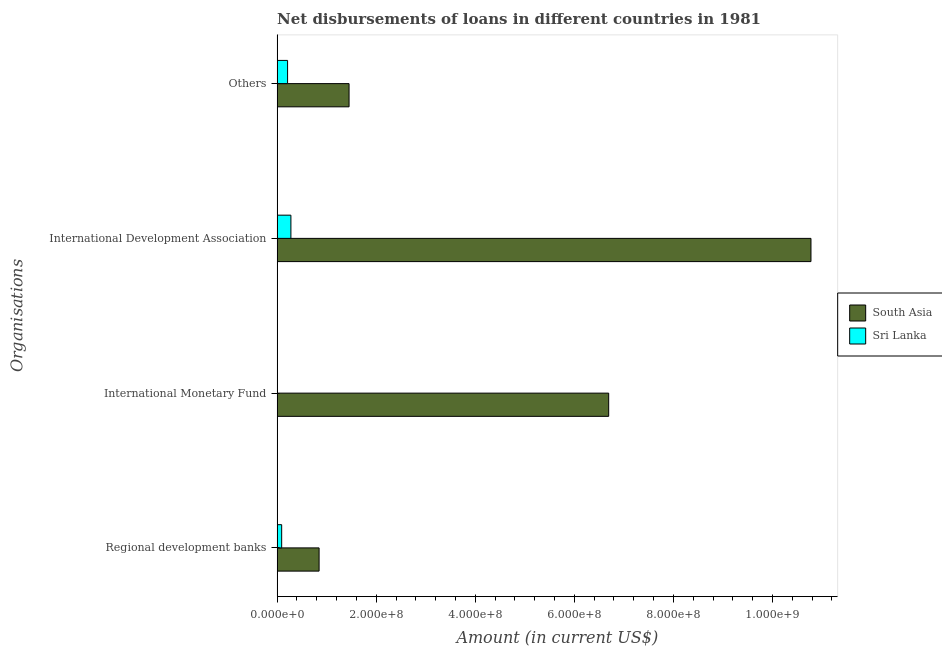How many different coloured bars are there?
Offer a very short reply. 2. How many groups of bars are there?
Your answer should be compact. 4. Are the number of bars per tick equal to the number of legend labels?
Offer a very short reply. Yes. How many bars are there on the 4th tick from the bottom?
Keep it short and to the point. 2. What is the label of the 4th group of bars from the top?
Ensure brevity in your answer.  Regional development banks. What is the amount of loan disimbursed by international monetary fund in Sri Lanka?
Give a very brief answer. 4.37e+05. Across all countries, what is the maximum amount of loan disimbursed by regional development banks?
Ensure brevity in your answer.  8.47e+07. Across all countries, what is the minimum amount of loan disimbursed by international development association?
Give a very brief answer. 2.78e+07. In which country was the amount of loan disimbursed by regional development banks maximum?
Provide a succinct answer. South Asia. In which country was the amount of loan disimbursed by regional development banks minimum?
Ensure brevity in your answer.  Sri Lanka. What is the total amount of loan disimbursed by international monetary fund in the graph?
Keep it short and to the point. 6.70e+08. What is the difference between the amount of loan disimbursed by international monetary fund in Sri Lanka and that in South Asia?
Give a very brief answer. -6.69e+08. What is the difference between the amount of loan disimbursed by regional development banks in Sri Lanka and the amount of loan disimbursed by other organisations in South Asia?
Provide a succinct answer. -1.36e+08. What is the average amount of loan disimbursed by regional development banks per country?
Offer a terse response. 4.70e+07. What is the difference between the amount of loan disimbursed by international monetary fund and amount of loan disimbursed by international development association in South Asia?
Your response must be concise. -4.08e+08. In how many countries, is the amount of loan disimbursed by international monetary fund greater than 1080000000 US$?
Keep it short and to the point. 0. What is the ratio of the amount of loan disimbursed by international development association in South Asia to that in Sri Lanka?
Your answer should be compact. 38.73. Is the amount of loan disimbursed by international development association in South Asia less than that in Sri Lanka?
Offer a terse response. No. Is the difference between the amount of loan disimbursed by regional development banks in Sri Lanka and South Asia greater than the difference between the amount of loan disimbursed by other organisations in Sri Lanka and South Asia?
Ensure brevity in your answer.  Yes. What is the difference between the highest and the second highest amount of loan disimbursed by international monetary fund?
Make the answer very short. 6.69e+08. What is the difference between the highest and the lowest amount of loan disimbursed by international monetary fund?
Provide a succinct answer. 6.69e+08. What does the 2nd bar from the top in International Monetary Fund represents?
Offer a terse response. South Asia. Is it the case that in every country, the sum of the amount of loan disimbursed by regional development banks and amount of loan disimbursed by international monetary fund is greater than the amount of loan disimbursed by international development association?
Make the answer very short. No. Are all the bars in the graph horizontal?
Provide a succinct answer. Yes. How many countries are there in the graph?
Make the answer very short. 2. What is the difference between two consecutive major ticks on the X-axis?
Ensure brevity in your answer.  2.00e+08. Are the values on the major ticks of X-axis written in scientific E-notation?
Your response must be concise. Yes. Does the graph contain any zero values?
Provide a short and direct response. No. Where does the legend appear in the graph?
Keep it short and to the point. Center right. How are the legend labels stacked?
Provide a short and direct response. Vertical. What is the title of the graph?
Ensure brevity in your answer.  Net disbursements of loans in different countries in 1981. Does "Belgium" appear as one of the legend labels in the graph?
Give a very brief answer. No. What is the label or title of the Y-axis?
Your answer should be compact. Organisations. What is the Amount (in current US$) of South Asia in Regional development banks?
Offer a terse response. 8.47e+07. What is the Amount (in current US$) of Sri Lanka in Regional development banks?
Your answer should be compact. 9.17e+06. What is the Amount (in current US$) in South Asia in International Monetary Fund?
Give a very brief answer. 6.69e+08. What is the Amount (in current US$) in Sri Lanka in International Monetary Fund?
Offer a terse response. 4.37e+05. What is the Amount (in current US$) of South Asia in International Development Association?
Ensure brevity in your answer.  1.08e+09. What is the Amount (in current US$) of Sri Lanka in International Development Association?
Make the answer very short. 2.78e+07. What is the Amount (in current US$) in South Asia in Others?
Your answer should be very brief. 1.45e+08. What is the Amount (in current US$) of Sri Lanka in Others?
Offer a terse response. 2.11e+07. Across all Organisations, what is the maximum Amount (in current US$) of South Asia?
Your answer should be compact. 1.08e+09. Across all Organisations, what is the maximum Amount (in current US$) of Sri Lanka?
Keep it short and to the point. 2.78e+07. Across all Organisations, what is the minimum Amount (in current US$) in South Asia?
Offer a very short reply. 8.47e+07. Across all Organisations, what is the minimum Amount (in current US$) in Sri Lanka?
Keep it short and to the point. 4.37e+05. What is the total Amount (in current US$) of South Asia in the graph?
Your answer should be very brief. 1.98e+09. What is the total Amount (in current US$) in Sri Lanka in the graph?
Give a very brief answer. 5.85e+07. What is the difference between the Amount (in current US$) of South Asia in Regional development banks and that in International Monetary Fund?
Ensure brevity in your answer.  -5.85e+08. What is the difference between the Amount (in current US$) of Sri Lanka in Regional development banks and that in International Monetary Fund?
Give a very brief answer. 8.73e+06. What is the difference between the Amount (in current US$) in South Asia in Regional development banks and that in International Development Association?
Make the answer very short. -9.93e+08. What is the difference between the Amount (in current US$) of Sri Lanka in Regional development banks and that in International Development Association?
Provide a short and direct response. -1.87e+07. What is the difference between the Amount (in current US$) in South Asia in Regional development banks and that in Others?
Offer a terse response. -6.05e+07. What is the difference between the Amount (in current US$) in Sri Lanka in Regional development banks and that in Others?
Make the answer very short. -1.19e+07. What is the difference between the Amount (in current US$) of South Asia in International Monetary Fund and that in International Development Association?
Give a very brief answer. -4.08e+08. What is the difference between the Amount (in current US$) in Sri Lanka in International Monetary Fund and that in International Development Association?
Provide a succinct answer. -2.74e+07. What is the difference between the Amount (in current US$) in South Asia in International Monetary Fund and that in Others?
Give a very brief answer. 5.24e+08. What is the difference between the Amount (in current US$) of Sri Lanka in International Monetary Fund and that in Others?
Keep it short and to the point. -2.07e+07. What is the difference between the Amount (in current US$) of South Asia in International Development Association and that in Others?
Provide a succinct answer. 9.33e+08. What is the difference between the Amount (in current US$) of Sri Lanka in International Development Association and that in Others?
Give a very brief answer. 6.72e+06. What is the difference between the Amount (in current US$) in South Asia in Regional development banks and the Amount (in current US$) in Sri Lanka in International Monetary Fund?
Provide a short and direct response. 8.43e+07. What is the difference between the Amount (in current US$) of South Asia in Regional development banks and the Amount (in current US$) of Sri Lanka in International Development Association?
Your answer should be very brief. 5.69e+07. What is the difference between the Amount (in current US$) of South Asia in Regional development banks and the Amount (in current US$) of Sri Lanka in Others?
Your response must be concise. 6.36e+07. What is the difference between the Amount (in current US$) in South Asia in International Monetary Fund and the Amount (in current US$) in Sri Lanka in International Development Association?
Your response must be concise. 6.42e+08. What is the difference between the Amount (in current US$) in South Asia in International Monetary Fund and the Amount (in current US$) in Sri Lanka in Others?
Make the answer very short. 6.48e+08. What is the difference between the Amount (in current US$) of South Asia in International Development Association and the Amount (in current US$) of Sri Lanka in Others?
Keep it short and to the point. 1.06e+09. What is the average Amount (in current US$) of South Asia per Organisations?
Your response must be concise. 4.94e+08. What is the average Amount (in current US$) of Sri Lanka per Organisations?
Your answer should be compact. 1.46e+07. What is the difference between the Amount (in current US$) of South Asia and Amount (in current US$) of Sri Lanka in Regional development banks?
Provide a short and direct response. 7.56e+07. What is the difference between the Amount (in current US$) of South Asia and Amount (in current US$) of Sri Lanka in International Monetary Fund?
Offer a terse response. 6.69e+08. What is the difference between the Amount (in current US$) of South Asia and Amount (in current US$) of Sri Lanka in International Development Association?
Your answer should be very brief. 1.05e+09. What is the difference between the Amount (in current US$) in South Asia and Amount (in current US$) in Sri Lanka in Others?
Your answer should be compact. 1.24e+08. What is the ratio of the Amount (in current US$) of South Asia in Regional development banks to that in International Monetary Fund?
Your answer should be very brief. 0.13. What is the ratio of the Amount (in current US$) of Sri Lanka in Regional development banks to that in International Monetary Fund?
Ensure brevity in your answer.  20.98. What is the ratio of the Amount (in current US$) in South Asia in Regional development banks to that in International Development Association?
Keep it short and to the point. 0.08. What is the ratio of the Amount (in current US$) in Sri Lanka in Regional development banks to that in International Development Association?
Provide a short and direct response. 0.33. What is the ratio of the Amount (in current US$) in South Asia in Regional development banks to that in Others?
Offer a terse response. 0.58. What is the ratio of the Amount (in current US$) in Sri Lanka in Regional development banks to that in Others?
Offer a very short reply. 0.43. What is the ratio of the Amount (in current US$) in South Asia in International Monetary Fund to that in International Development Association?
Give a very brief answer. 0.62. What is the ratio of the Amount (in current US$) in Sri Lanka in International Monetary Fund to that in International Development Association?
Make the answer very short. 0.02. What is the ratio of the Amount (in current US$) of South Asia in International Monetary Fund to that in Others?
Your answer should be compact. 4.61. What is the ratio of the Amount (in current US$) in Sri Lanka in International Monetary Fund to that in Others?
Your response must be concise. 0.02. What is the ratio of the Amount (in current US$) in South Asia in International Development Association to that in Others?
Keep it short and to the point. 7.42. What is the ratio of the Amount (in current US$) in Sri Lanka in International Development Association to that in Others?
Your answer should be compact. 1.32. What is the difference between the highest and the second highest Amount (in current US$) in South Asia?
Your answer should be very brief. 4.08e+08. What is the difference between the highest and the second highest Amount (in current US$) of Sri Lanka?
Keep it short and to the point. 6.72e+06. What is the difference between the highest and the lowest Amount (in current US$) in South Asia?
Your response must be concise. 9.93e+08. What is the difference between the highest and the lowest Amount (in current US$) of Sri Lanka?
Keep it short and to the point. 2.74e+07. 